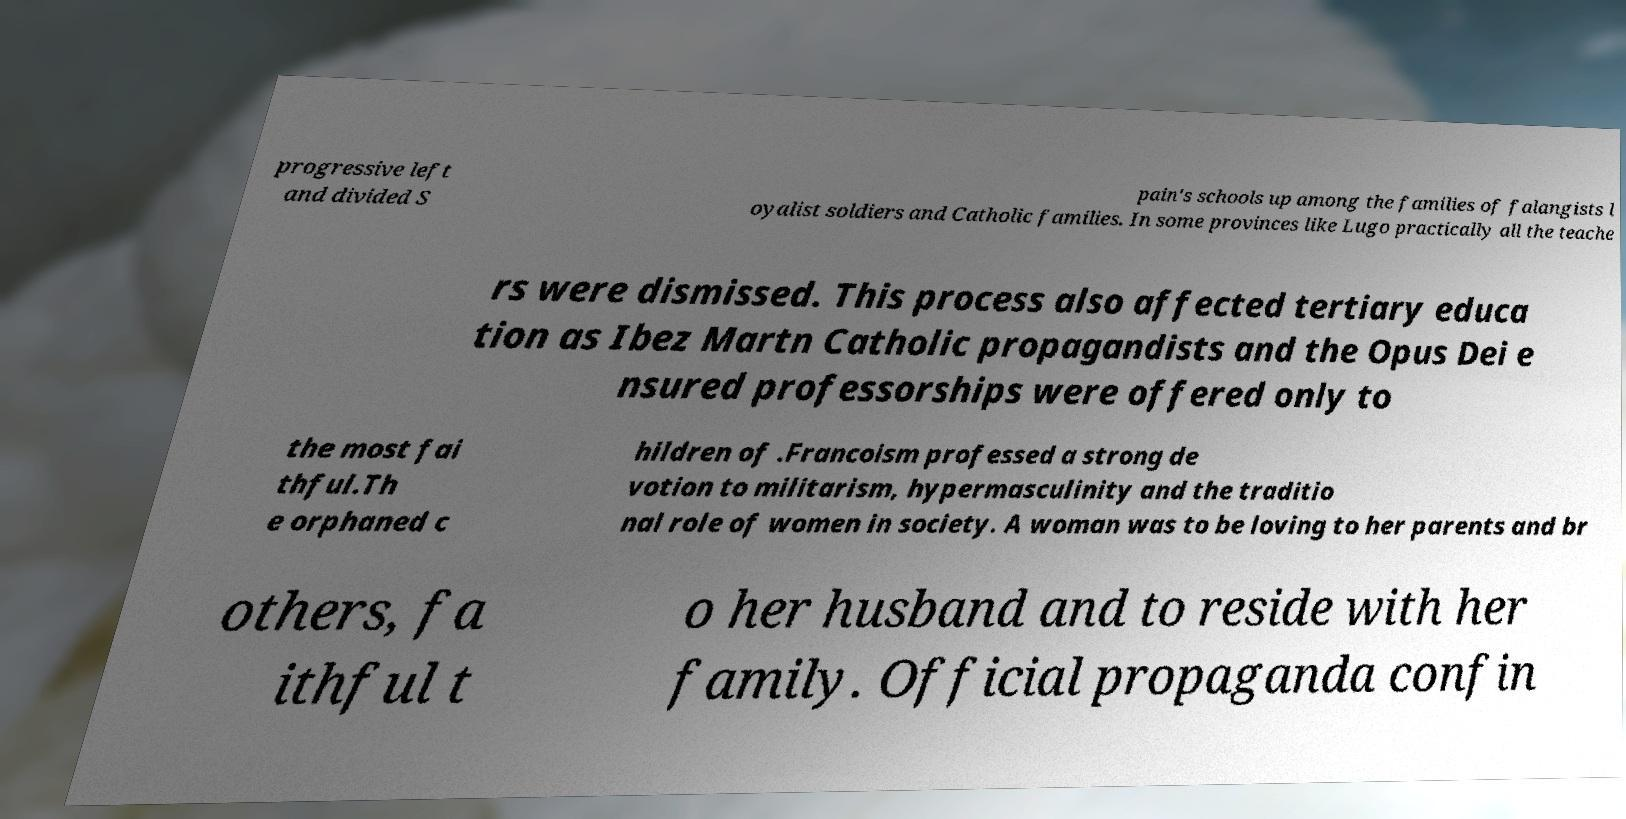Can you accurately transcribe the text from the provided image for me? progressive left and divided S pain's schools up among the families of falangists l oyalist soldiers and Catholic families. In some provinces like Lugo practically all the teache rs were dismissed. This process also affected tertiary educa tion as Ibez Martn Catholic propagandists and the Opus Dei e nsured professorships were offered only to the most fai thful.Th e orphaned c hildren of .Francoism professed a strong de votion to militarism, hypermasculinity and the traditio nal role of women in society. A woman was to be loving to her parents and br others, fa ithful t o her husband and to reside with her family. Official propaganda confin 